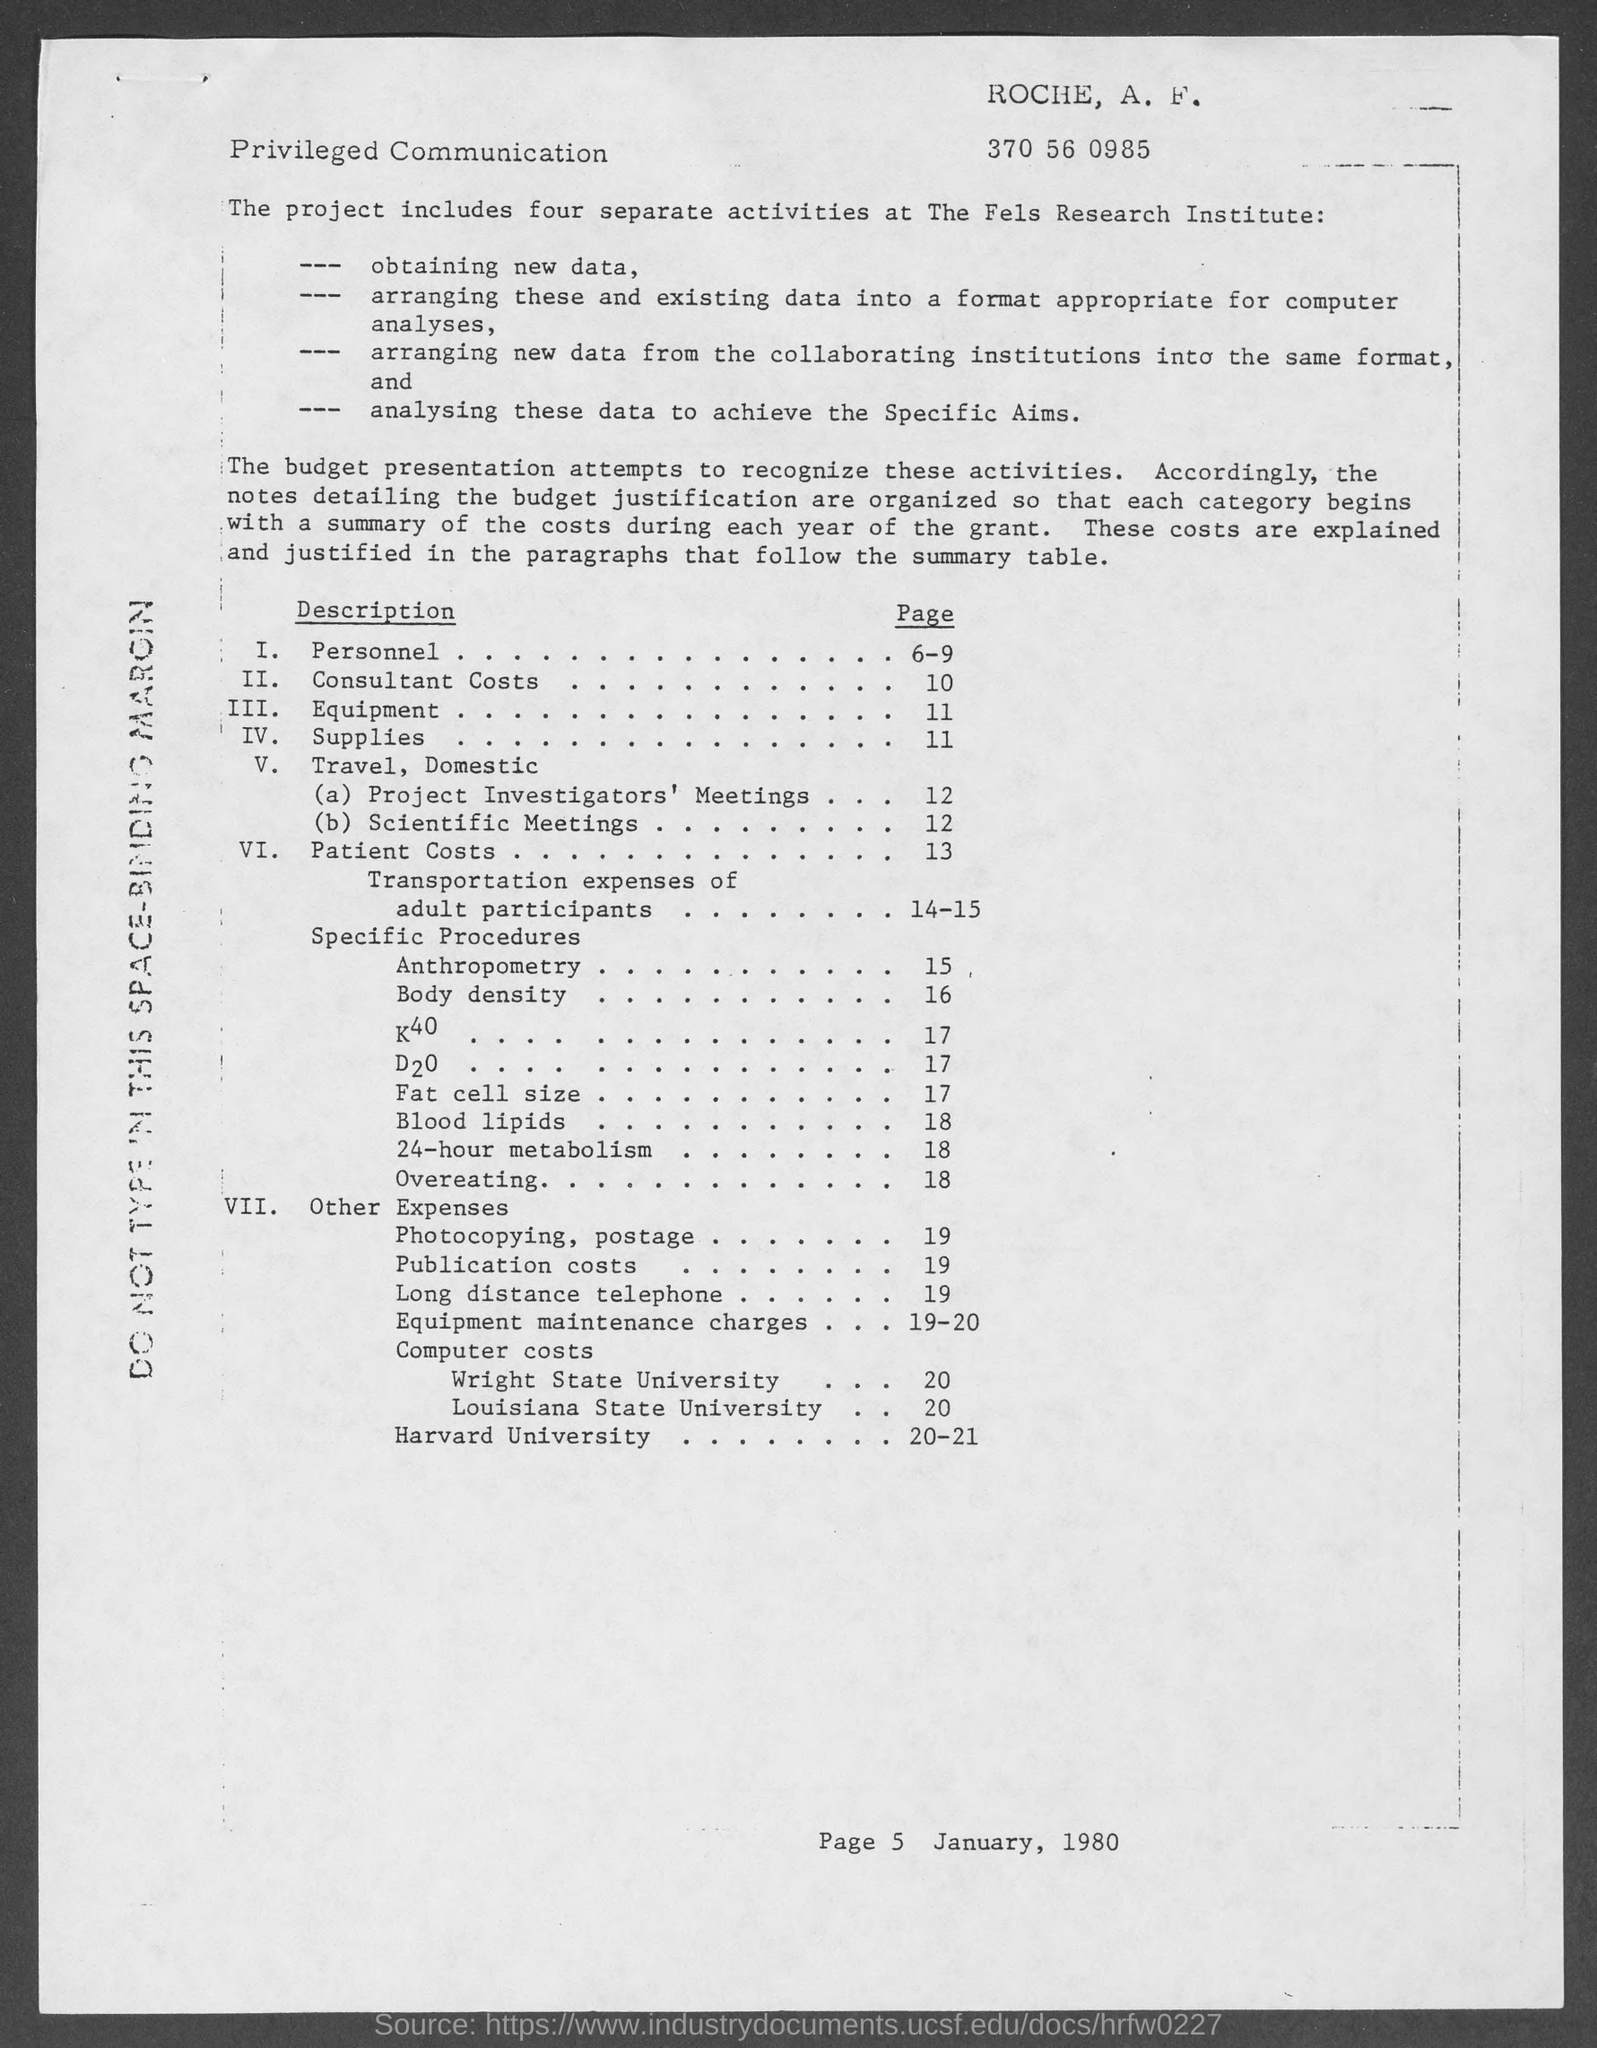In which page number is  "consultant cost"?
Your answer should be compact. 10. In which page number is  "scientific Meetings"?
Give a very brief answer. 12. How many separate activities does project includes?
Keep it short and to the point. Four. In which page number is  "personnel"?
Your answer should be very brief. 6-9. 